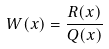Convert formula to latex. <formula><loc_0><loc_0><loc_500><loc_500>W ( x ) = \frac { R ( x ) } { Q ( x ) }</formula> 